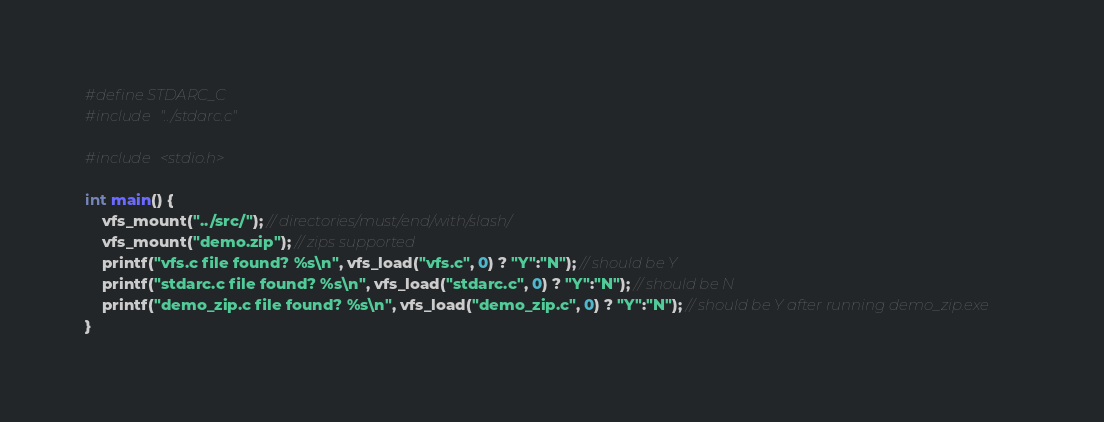<code> <loc_0><loc_0><loc_500><loc_500><_C_>#define STDARC_C
#include "../stdarc.c"

#include <stdio.h>

int main() {
    vfs_mount("../src/"); // directories/must/end/with/slash/
    vfs_mount("demo.zip"); // zips supported
    printf("vfs.c file found? %s\n", vfs_load("vfs.c", 0) ? "Y":"N"); // should be Y
    printf("stdarc.c file found? %s\n", vfs_load("stdarc.c", 0) ? "Y":"N"); // should be N
    printf("demo_zip.c file found? %s\n", vfs_load("demo_zip.c", 0) ? "Y":"N"); // should be Y after running demo_zip.exe
}
</code> 